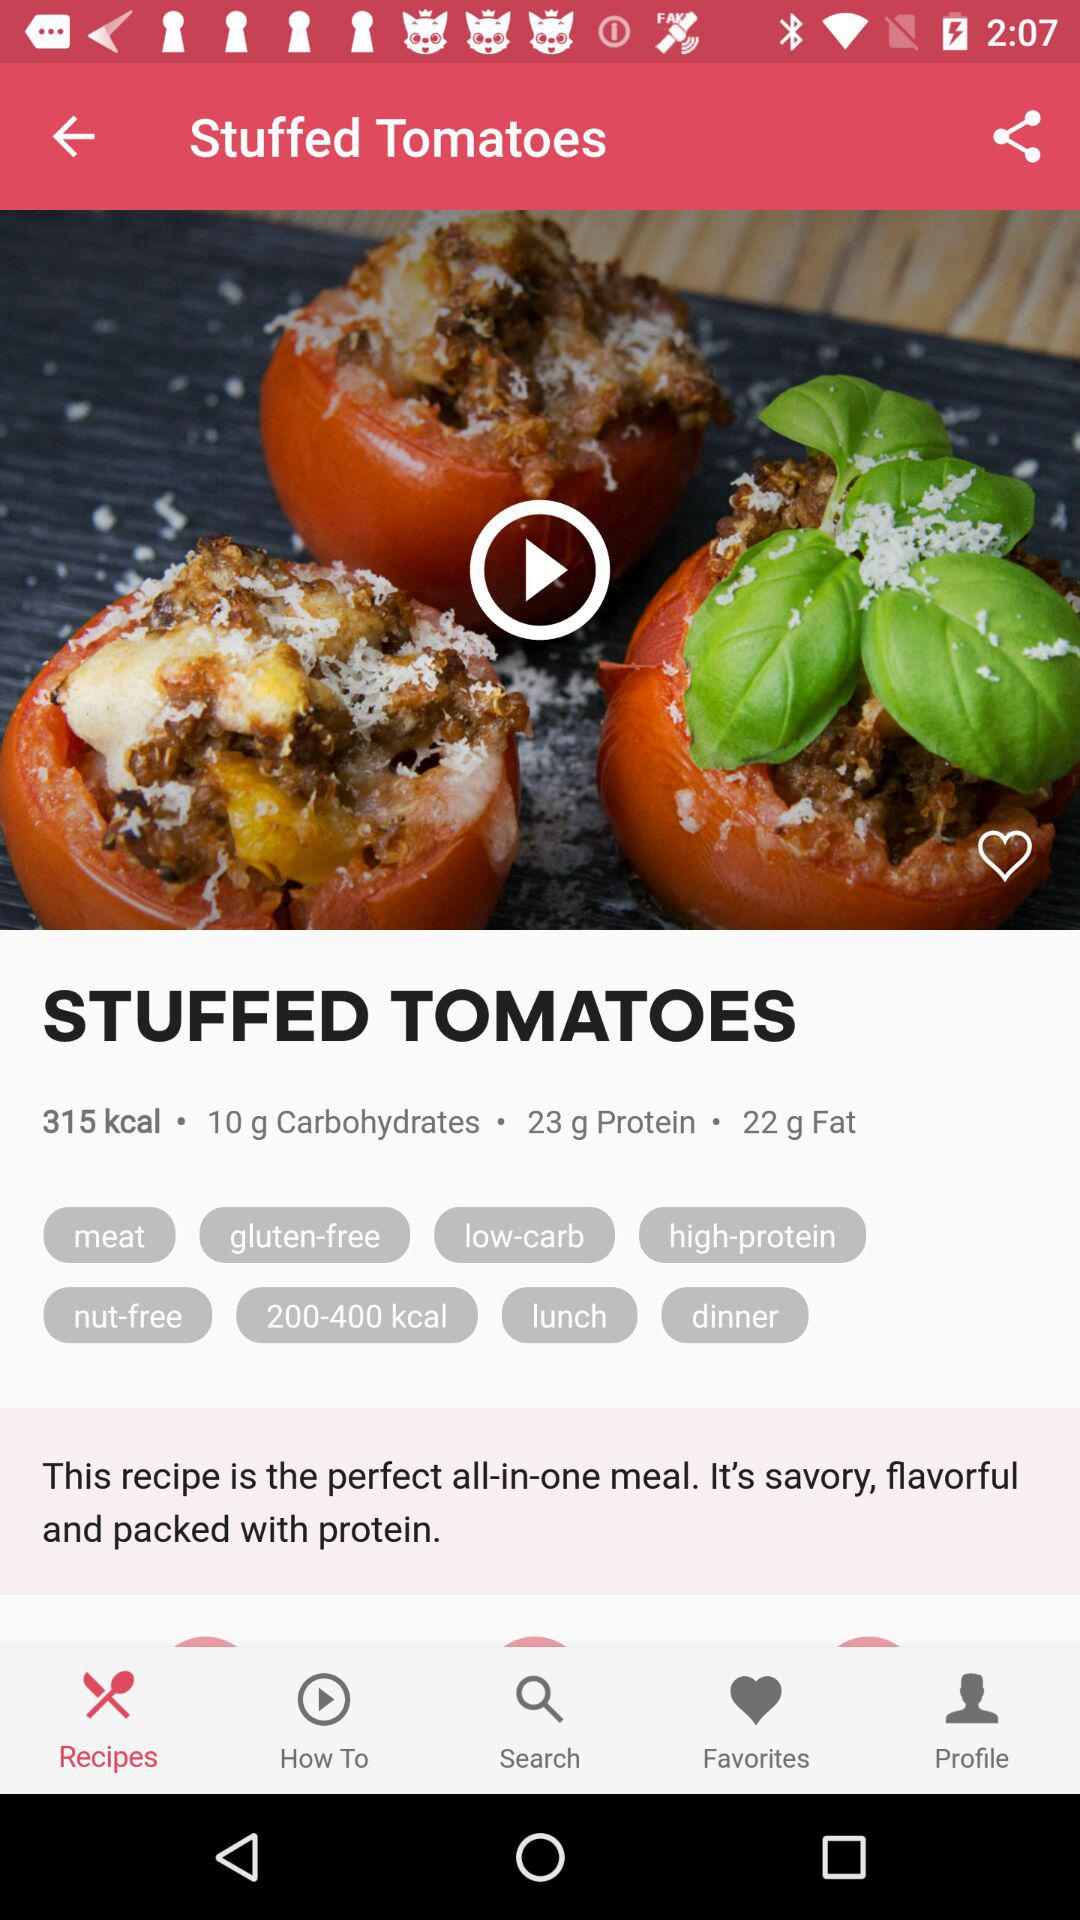What is the name of the recipe? The name of the recipe is "Stuffed Tomatoes". 